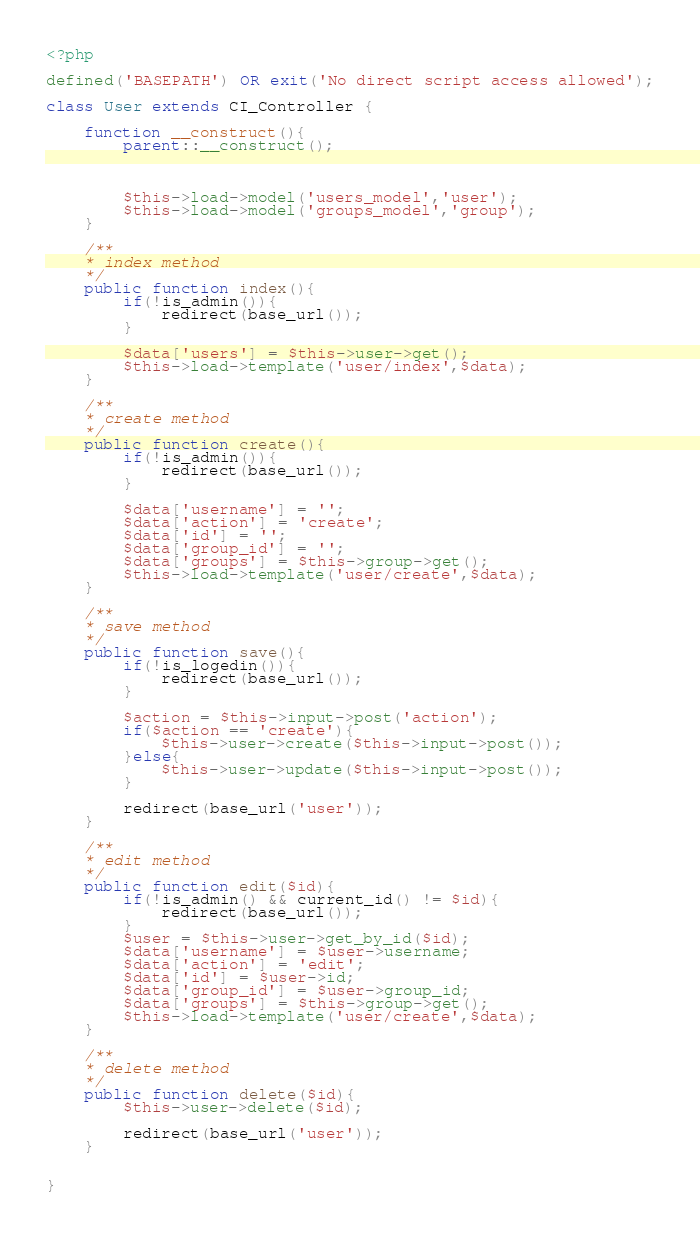<code> <loc_0><loc_0><loc_500><loc_500><_PHP_><?php 

defined('BASEPATH') OR exit('No direct script access allowed');

class User extends CI_Controller {

	function __construct(){
        parent::__construct();

        

        $this->load->model('users_model','user');
        $this->load->model('groups_model','group');
    }

    /**
    * index method
    */
    public function index(){
        if(!is_admin()){
            redirect(base_url());   
        }

    	$data['users'] = $this->user->get();
    	$this->load->template('user/index',$data);
    }

    /**
    * create method
    */
    public function create(){
        if(!is_admin()){
            redirect(base_url());   
        }

    	$data['username'] = '';
    	$data['action'] = 'create';
    	$data['id'] = '';
    	$data['group_id'] = '';
    	$data['groups'] = $this->group->get();
    	$this->load->template('user/create',$data);
    }

    /**
    * save method
    */
    public function save(){
        if(!is_logedin()){
            redirect(base_url());   
        }

    	$action = $this->input->post('action');
    	if($action == 'create'){
    		$this->user->create($this->input->post());
    	}else{
    		$this->user->update($this->input->post());
    	}

    	redirect(base_url('user'));
    }

    /**
    * edit method
    */
    public function edit($id){
        if(!is_admin() && current_id() != $id){
            redirect(base_url());   
        }
        $user = $this->user->get_by_id($id);
        $data['username'] = $user->username;
        $data['action'] = 'edit';
        $data['id'] = $user->id;
        $data['group_id'] = $user->group_id;
        $data['groups'] = $this->group->get();
        $this->load->template('user/create',$data);
    }

    /**
    * delete method
    */
    public function delete($id){
        $this->user->delete($id);

        redirect(base_url('user'));
    }

   
}</code> 